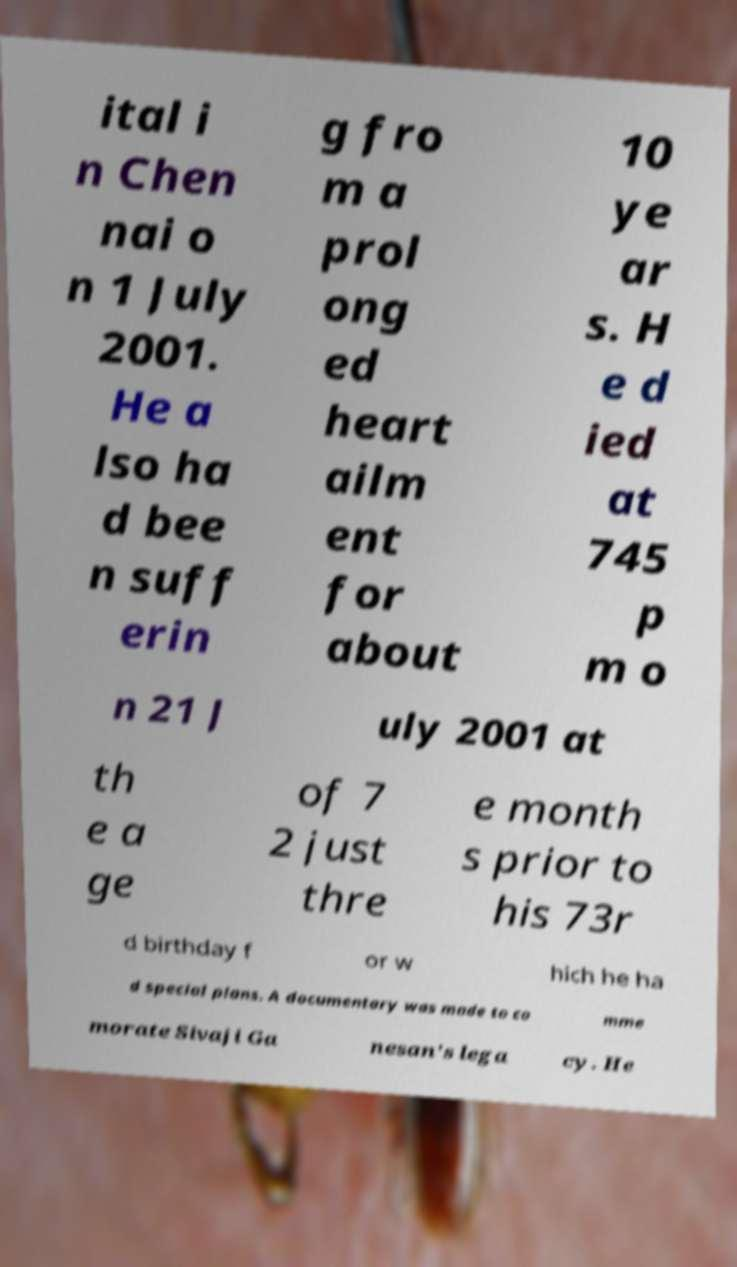Can you accurately transcribe the text from the provided image for me? ital i n Chen nai o n 1 July 2001. He a lso ha d bee n suff erin g fro m a prol ong ed heart ailm ent for about 10 ye ar s. H e d ied at 745 p m o n 21 J uly 2001 at th e a ge of 7 2 just thre e month s prior to his 73r d birthday f or w hich he ha d special plans. A documentary was made to co mme morate Sivaji Ga nesan's lega cy. He 